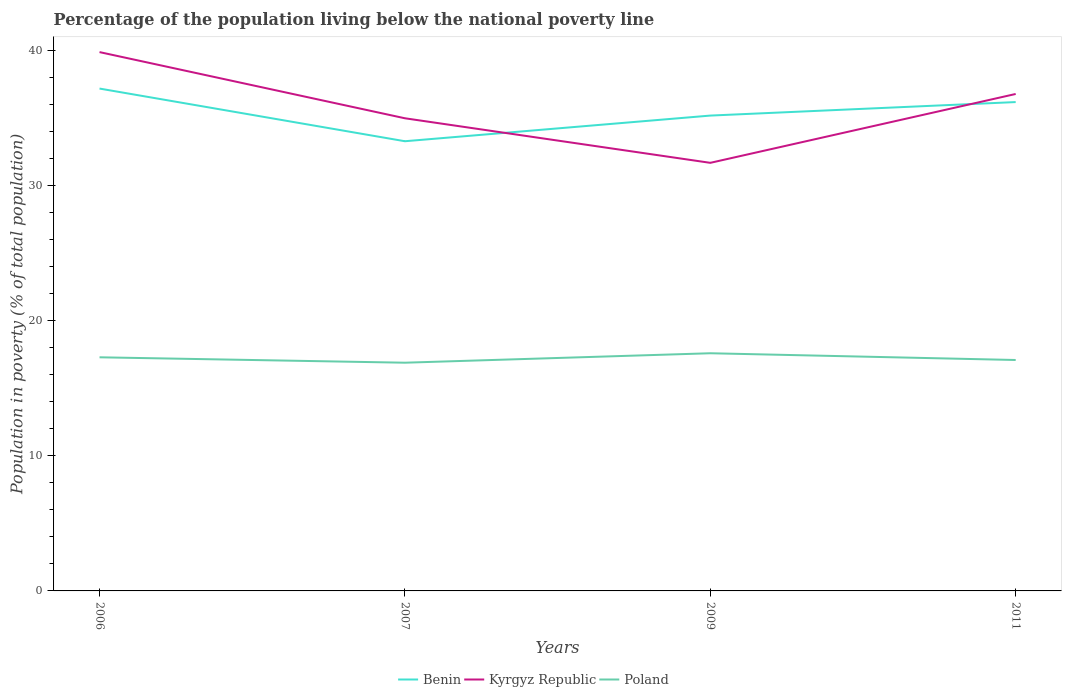How many different coloured lines are there?
Provide a short and direct response. 3. Does the line corresponding to Benin intersect with the line corresponding to Poland?
Keep it short and to the point. No. Is the number of lines equal to the number of legend labels?
Give a very brief answer. Yes. Across all years, what is the maximum percentage of the population living below the national poverty line in Benin?
Provide a short and direct response. 33.3. What is the difference between the highest and the second highest percentage of the population living below the national poverty line in Poland?
Provide a succinct answer. 0.7. What is the difference between the highest and the lowest percentage of the population living below the national poverty line in Kyrgyz Republic?
Provide a succinct answer. 2. How many years are there in the graph?
Offer a very short reply. 4. What is the difference between two consecutive major ticks on the Y-axis?
Provide a succinct answer. 10. Are the values on the major ticks of Y-axis written in scientific E-notation?
Ensure brevity in your answer.  No. Does the graph contain any zero values?
Give a very brief answer. No. Where does the legend appear in the graph?
Give a very brief answer. Bottom center. How many legend labels are there?
Provide a short and direct response. 3. What is the title of the graph?
Make the answer very short. Percentage of the population living below the national poverty line. Does "Vanuatu" appear as one of the legend labels in the graph?
Offer a terse response. No. What is the label or title of the X-axis?
Offer a very short reply. Years. What is the label or title of the Y-axis?
Your answer should be very brief. Population in poverty (% of total population). What is the Population in poverty (% of total population) of Benin in 2006?
Keep it short and to the point. 37.2. What is the Population in poverty (% of total population) of Kyrgyz Republic in 2006?
Make the answer very short. 39.9. What is the Population in poverty (% of total population) in Poland in 2006?
Give a very brief answer. 17.3. What is the Population in poverty (% of total population) in Benin in 2007?
Your answer should be very brief. 33.3. What is the Population in poverty (% of total population) of Benin in 2009?
Give a very brief answer. 35.2. What is the Population in poverty (% of total population) in Kyrgyz Republic in 2009?
Provide a succinct answer. 31.7. What is the Population in poverty (% of total population) of Benin in 2011?
Your response must be concise. 36.2. What is the Population in poverty (% of total population) of Kyrgyz Republic in 2011?
Ensure brevity in your answer.  36.8. What is the Population in poverty (% of total population) in Poland in 2011?
Your response must be concise. 17.1. Across all years, what is the maximum Population in poverty (% of total population) in Benin?
Make the answer very short. 37.2. Across all years, what is the maximum Population in poverty (% of total population) in Kyrgyz Republic?
Offer a terse response. 39.9. Across all years, what is the maximum Population in poverty (% of total population) in Poland?
Provide a short and direct response. 17.6. Across all years, what is the minimum Population in poverty (% of total population) in Benin?
Ensure brevity in your answer.  33.3. Across all years, what is the minimum Population in poverty (% of total population) in Kyrgyz Republic?
Offer a terse response. 31.7. Across all years, what is the minimum Population in poverty (% of total population) of Poland?
Give a very brief answer. 16.9. What is the total Population in poverty (% of total population) of Benin in the graph?
Offer a terse response. 141.9. What is the total Population in poverty (% of total population) in Kyrgyz Republic in the graph?
Your answer should be very brief. 143.4. What is the total Population in poverty (% of total population) of Poland in the graph?
Offer a very short reply. 68.9. What is the difference between the Population in poverty (% of total population) in Benin in 2006 and that in 2007?
Provide a succinct answer. 3.9. What is the difference between the Population in poverty (% of total population) in Benin in 2006 and that in 2009?
Offer a terse response. 2. What is the difference between the Population in poverty (% of total population) in Kyrgyz Republic in 2006 and that in 2009?
Give a very brief answer. 8.2. What is the difference between the Population in poverty (% of total population) of Poland in 2006 and that in 2009?
Ensure brevity in your answer.  -0.3. What is the difference between the Population in poverty (% of total population) of Poland in 2006 and that in 2011?
Your answer should be compact. 0.2. What is the difference between the Population in poverty (% of total population) of Kyrgyz Republic in 2007 and that in 2011?
Your response must be concise. -1.8. What is the difference between the Population in poverty (% of total population) in Poland in 2007 and that in 2011?
Keep it short and to the point. -0.2. What is the difference between the Population in poverty (% of total population) in Benin in 2009 and that in 2011?
Provide a succinct answer. -1. What is the difference between the Population in poverty (% of total population) in Kyrgyz Republic in 2009 and that in 2011?
Give a very brief answer. -5.1. What is the difference between the Population in poverty (% of total population) of Poland in 2009 and that in 2011?
Keep it short and to the point. 0.5. What is the difference between the Population in poverty (% of total population) of Benin in 2006 and the Population in poverty (% of total population) of Poland in 2007?
Ensure brevity in your answer.  20.3. What is the difference between the Population in poverty (% of total population) in Benin in 2006 and the Population in poverty (% of total population) in Poland in 2009?
Give a very brief answer. 19.6. What is the difference between the Population in poverty (% of total population) of Kyrgyz Republic in 2006 and the Population in poverty (% of total population) of Poland in 2009?
Your response must be concise. 22.3. What is the difference between the Population in poverty (% of total population) in Benin in 2006 and the Population in poverty (% of total population) in Kyrgyz Republic in 2011?
Your answer should be very brief. 0.4. What is the difference between the Population in poverty (% of total population) in Benin in 2006 and the Population in poverty (% of total population) in Poland in 2011?
Keep it short and to the point. 20.1. What is the difference between the Population in poverty (% of total population) in Kyrgyz Republic in 2006 and the Population in poverty (% of total population) in Poland in 2011?
Ensure brevity in your answer.  22.8. What is the difference between the Population in poverty (% of total population) in Benin in 2007 and the Population in poverty (% of total population) in Kyrgyz Republic in 2009?
Your answer should be compact. 1.6. What is the difference between the Population in poverty (% of total population) of Kyrgyz Republic in 2007 and the Population in poverty (% of total population) of Poland in 2009?
Your answer should be very brief. 17.4. What is the difference between the Population in poverty (% of total population) of Benin in 2007 and the Population in poverty (% of total population) of Kyrgyz Republic in 2011?
Ensure brevity in your answer.  -3.5. What is the difference between the Population in poverty (% of total population) of Benin in 2007 and the Population in poverty (% of total population) of Poland in 2011?
Offer a terse response. 16.2. What is the average Population in poverty (% of total population) of Benin per year?
Provide a short and direct response. 35.48. What is the average Population in poverty (% of total population) in Kyrgyz Republic per year?
Your response must be concise. 35.85. What is the average Population in poverty (% of total population) of Poland per year?
Your answer should be compact. 17.23. In the year 2006, what is the difference between the Population in poverty (% of total population) of Benin and Population in poverty (% of total population) of Kyrgyz Republic?
Provide a succinct answer. -2.7. In the year 2006, what is the difference between the Population in poverty (% of total population) of Benin and Population in poverty (% of total population) of Poland?
Provide a succinct answer. 19.9. In the year 2006, what is the difference between the Population in poverty (% of total population) of Kyrgyz Republic and Population in poverty (% of total population) of Poland?
Ensure brevity in your answer.  22.6. In the year 2007, what is the difference between the Population in poverty (% of total population) in Benin and Population in poverty (% of total population) in Kyrgyz Republic?
Offer a terse response. -1.7. In the year 2007, what is the difference between the Population in poverty (% of total population) of Benin and Population in poverty (% of total population) of Poland?
Provide a succinct answer. 16.4. In the year 2009, what is the difference between the Population in poverty (% of total population) of Benin and Population in poverty (% of total population) of Poland?
Make the answer very short. 17.6. In the year 2009, what is the difference between the Population in poverty (% of total population) of Kyrgyz Republic and Population in poverty (% of total population) of Poland?
Your answer should be compact. 14.1. In the year 2011, what is the difference between the Population in poverty (% of total population) of Benin and Population in poverty (% of total population) of Kyrgyz Republic?
Ensure brevity in your answer.  -0.6. What is the ratio of the Population in poverty (% of total population) of Benin in 2006 to that in 2007?
Offer a terse response. 1.12. What is the ratio of the Population in poverty (% of total population) of Kyrgyz Republic in 2006 to that in 2007?
Your response must be concise. 1.14. What is the ratio of the Population in poverty (% of total population) of Poland in 2006 to that in 2007?
Your response must be concise. 1.02. What is the ratio of the Population in poverty (% of total population) of Benin in 2006 to that in 2009?
Ensure brevity in your answer.  1.06. What is the ratio of the Population in poverty (% of total population) of Kyrgyz Republic in 2006 to that in 2009?
Your answer should be very brief. 1.26. What is the ratio of the Population in poverty (% of total population) of Benin in 2006 to that in 2011?
Your response must be concise. 1.03. What is the ratio of the Population in poverty (% of total population) of Kyrgyz Republic in 2006 to that in 2011?
Make the answer very short. 1.08. What is the ratio of the Population in poverty (% of total population) of Poland in 2006 to that in 2011?
Your answer should be compact. 1.01. What is the ratio of the Population in poverty (% of total population) in Benin in 2007 to that in 2009?
Provide a short and direct response. 0.95. What is the ratio of the Population in poverty (% of total population) of Kyrgyz Republic in 2007 to that in 2009?
Provide a short and direct response. 1.1. What is the ratio of the Population in poverty (% of total population) in Poland in 2007 to that in 2009?
Offer a terse response. 0.96. What is the ratio of the Population in poverty (% of total population) in Benin in 2007 to that in 2011?
Offer a very short reply. 0.92. What is the ratio of the Population in poverty (% of total population) in Kyrgyz Republic in 2007 to that in 2011?
Make the answer very short. 0.95. What is the ratio of the Population in poverty (% of total population) in Poland in 2007 to that in 2011?
Your answer should be compact. 0.99. What is the ratio of the Population in poverty (% of total population) in Benin in 2009 to that in 2011?
Provide a succinct answer. 0.97. What is the ratio of the Population in poverty (% of total population) in Kyrgyz Republic in 2009 to that in 2011?
Your answer should be compact. 0.86. What is the ratio of the Population in poverty (% of total population) of Poland in 2009 to that in 2011?
Give a very brief answer. 1.03. What is the difference between the highest and the second highest Population in poverty (% of total population) of Poland?
Your answer should be compact. 0.3. What is the difference between the highest and the lowest Population in poverty (% of total population) in Benin?
Ensure brevity in your answer.  3.9. What is the difference between the highest and the lowest Population in poverty (% of total population) in Kyrgyz Republic?
Your answer should be compact. 8.2. What is the difference between the highest and the lowest Population in poverty (% of total population) of Poland?
Ensure brevity in your answer.  0.7. 